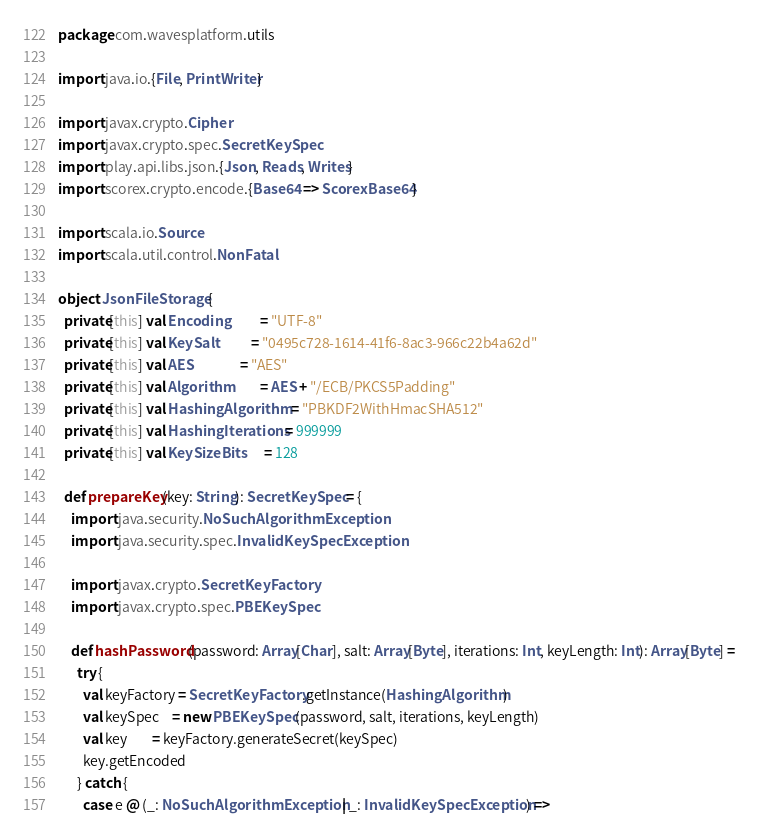Convert code to text. <code><loc_0><loc_0><loc_500><loc_500><_Scala_>package com.wavesplatform.utils

import java.io.{File, PrintWriter}

import javax.crypto.Cipher
import javax.crypto.spec.SecretKeySpec
import play.api.libs.json.{Json, Reads, Writes}
import scorex.crypto.encode.{Base64 => ScorexBase64}

import scala.io.Source
import scala.util.control.NonFatal

object JsonFileStorage {
  private[this] val Encoding          = "UTF-8"
  private[this] val KeySalt           = "0495c728-1614-41f6-8ac3-966c22b4a62d"
  private[this] val AES               = "AES"
  private[this] val Algorithm         = AES + "/ECB/PKCS5Padding"
  private[this] val HashingAlgorithm  = "PBKDF2WithHmacSHA512"
  private[this] val HashingIterations = 999999
  private[this] val KeySizeBits       = 128

  def prepareKey(key: String): SecretKeySpec = {
    import java.security.NoSuchAlgorithmException
    import java.security.spec.InvalidKeySpecException

    import javax.crypto.SecretKeyFactory
    import javax.crypto.spec.PBEKeySpec

    def hashPassword(password: Array[Char], salt: Array[Byte], iterations: Int, keyLength: Int): Array[Byte] =
      try {
        val keyFactory = SecretKeyFactory.getInstance(HashingAlgorithm)
        val keySpec    = new PBEKeySpec(password, salt, iterations, keyLength)
        val key        = keyFactory.generateSecret(keySpec)
        key.getEncoded
      } catch {
        case e @ (_: NoSuchAlgorithmException | _: InvalidKeySpecException) =></code> 